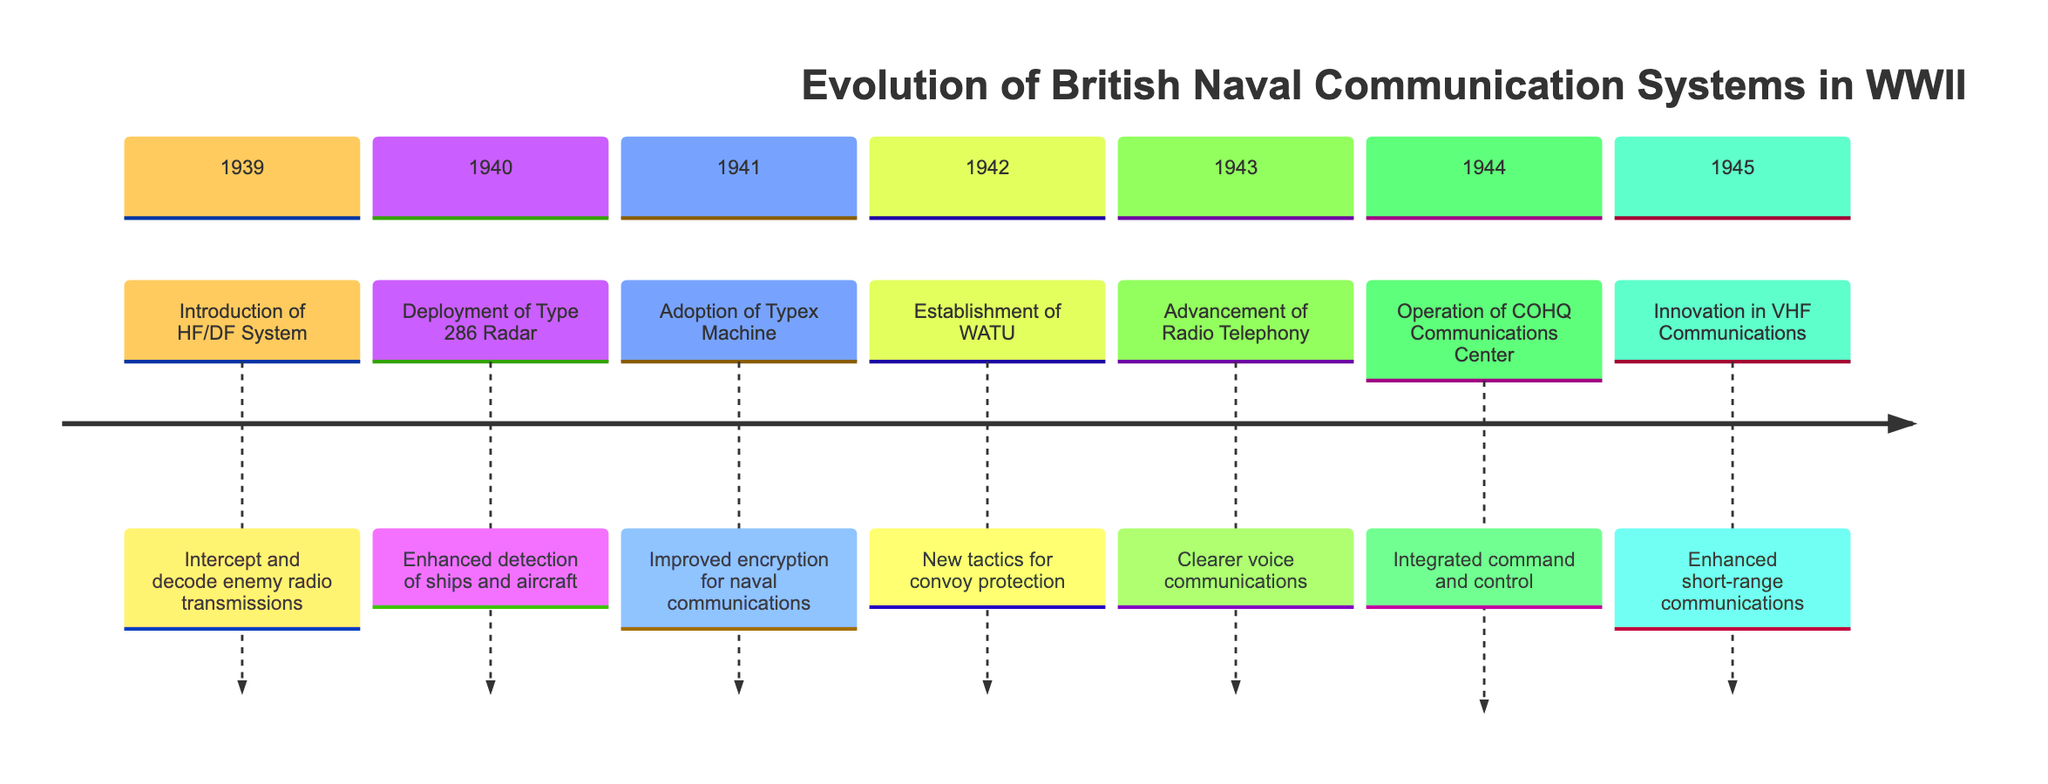What year was the HF/DF system introduced? The timeline clearly states that the HF/DF system was introduced in 1939.
Answer: 1939 What event occurred in 1941? According to the timeline, the event in 1941 is the adoption of the Typex machine.
Answer: Adoption of Typex Machine How many years are between the deployment of the Type 286 Radar and the establishment of WATU? The deployment of the Type 286 Radar was in 1940 and WATU was established in 1942. The difference between these two years is 2 years.
Answer: 2 years Which communication system was innovated in 1945? The timeline specifies that Very High Frequency (VHF) communications were innovated in 1945.
Answer: Innovation in Very High Frequency (VHF) Communications What significant advancement was made in 1943? The timeline notes that advancement in radio telephony occurred in 1943, allowing for clearer voice communications.
Answer: Advancement of Radio Telephony Which event focused on convoy protection tactics? The establishment of WATU in 1942 was specifically focused on developing new tactics for convoy protection.
Answer: Establishment of WATU What communication technology improved command and control in 1944? The operation of the Combined Operations Headquarters (COHQ) Communications Center in 1944 improved command and control.
Answer: Operation of Combined Operations Headquarters (COHQ) Communications Center Which event directly addressed naval communications security? The adoption of the Typex machine in 1941 directly addressed naval communications security by improving encryption.
Answer: Adoption of Typex Machine In which year did the British Navy enhance its detection capabilities with radar? The deployment of the Type 286 Radar, which enhanced detection capabilities, occurred in 1940.
Answer: 1940 